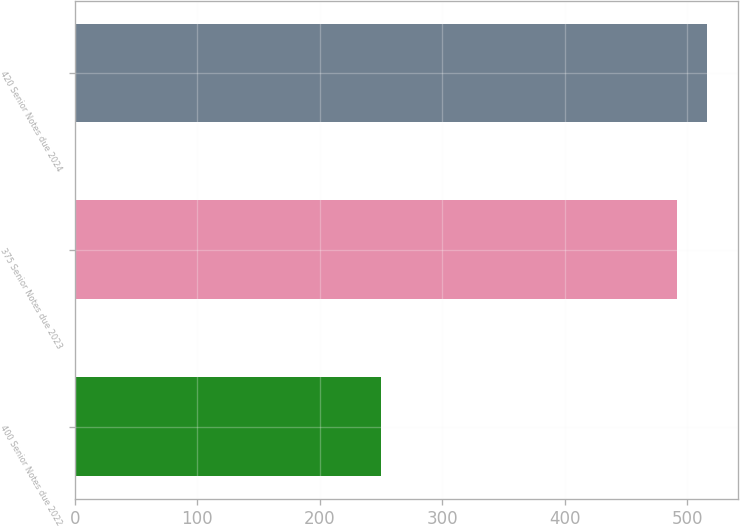Convert chart. <chart><loc_0><loc_0><loc_500><loc_500><bar_chart><fcel>400 Senior Notes due 2022<fcel>375 Senior Notes due 2023<fcel>420 Senior Notes due 2024<nl><fcel>250.3<fcel>491.4<fcel>515.63<nl></chart> 